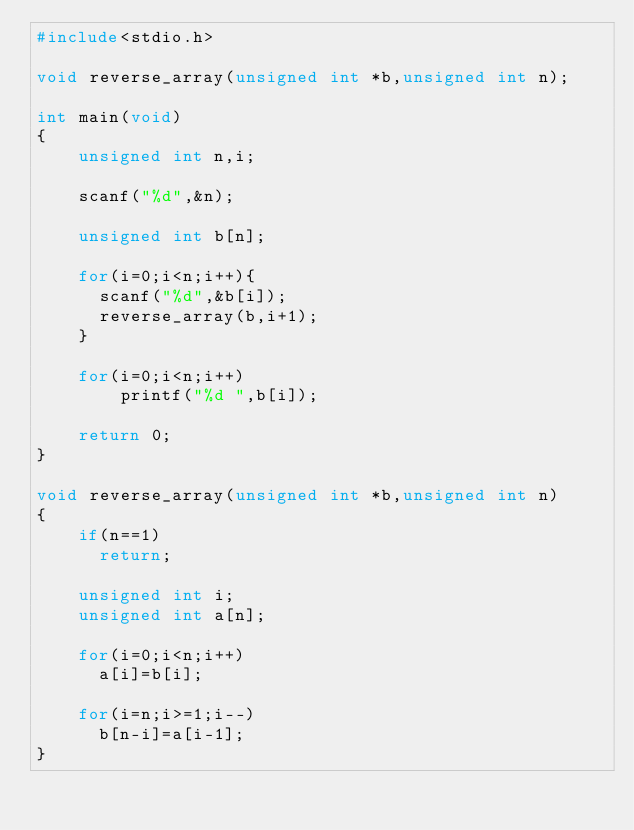Convert code to text. <code><loc_0><loc_0><loc_500><loc_500><_C_>#include<stdio.h>

void reverse_array(unsigned int *b,unsigned int n);

int main(void)
{
    unsigned int n,i;

    scanf("%d",&n);

    unsigned int b[n];

    for(i=0;i<n;i++){
      scanf("%d",&b[i]);
      reverse_array(b,i+1);
    }

    for(i=0;i<n;i++)
        printf("%d ",b[i]);

    return 0;
}

void reverse_array(unsigned int *b,unsigned int n)
{
    if(n==1)
      return;

    unsigned int i;
    unsigned int a[n];

    for(i=0;i<n;i++)
      a[i]=b[i];

    for(i=n;i>=1;i--)
      b[n-i]=a[i-1];
}
</code> 